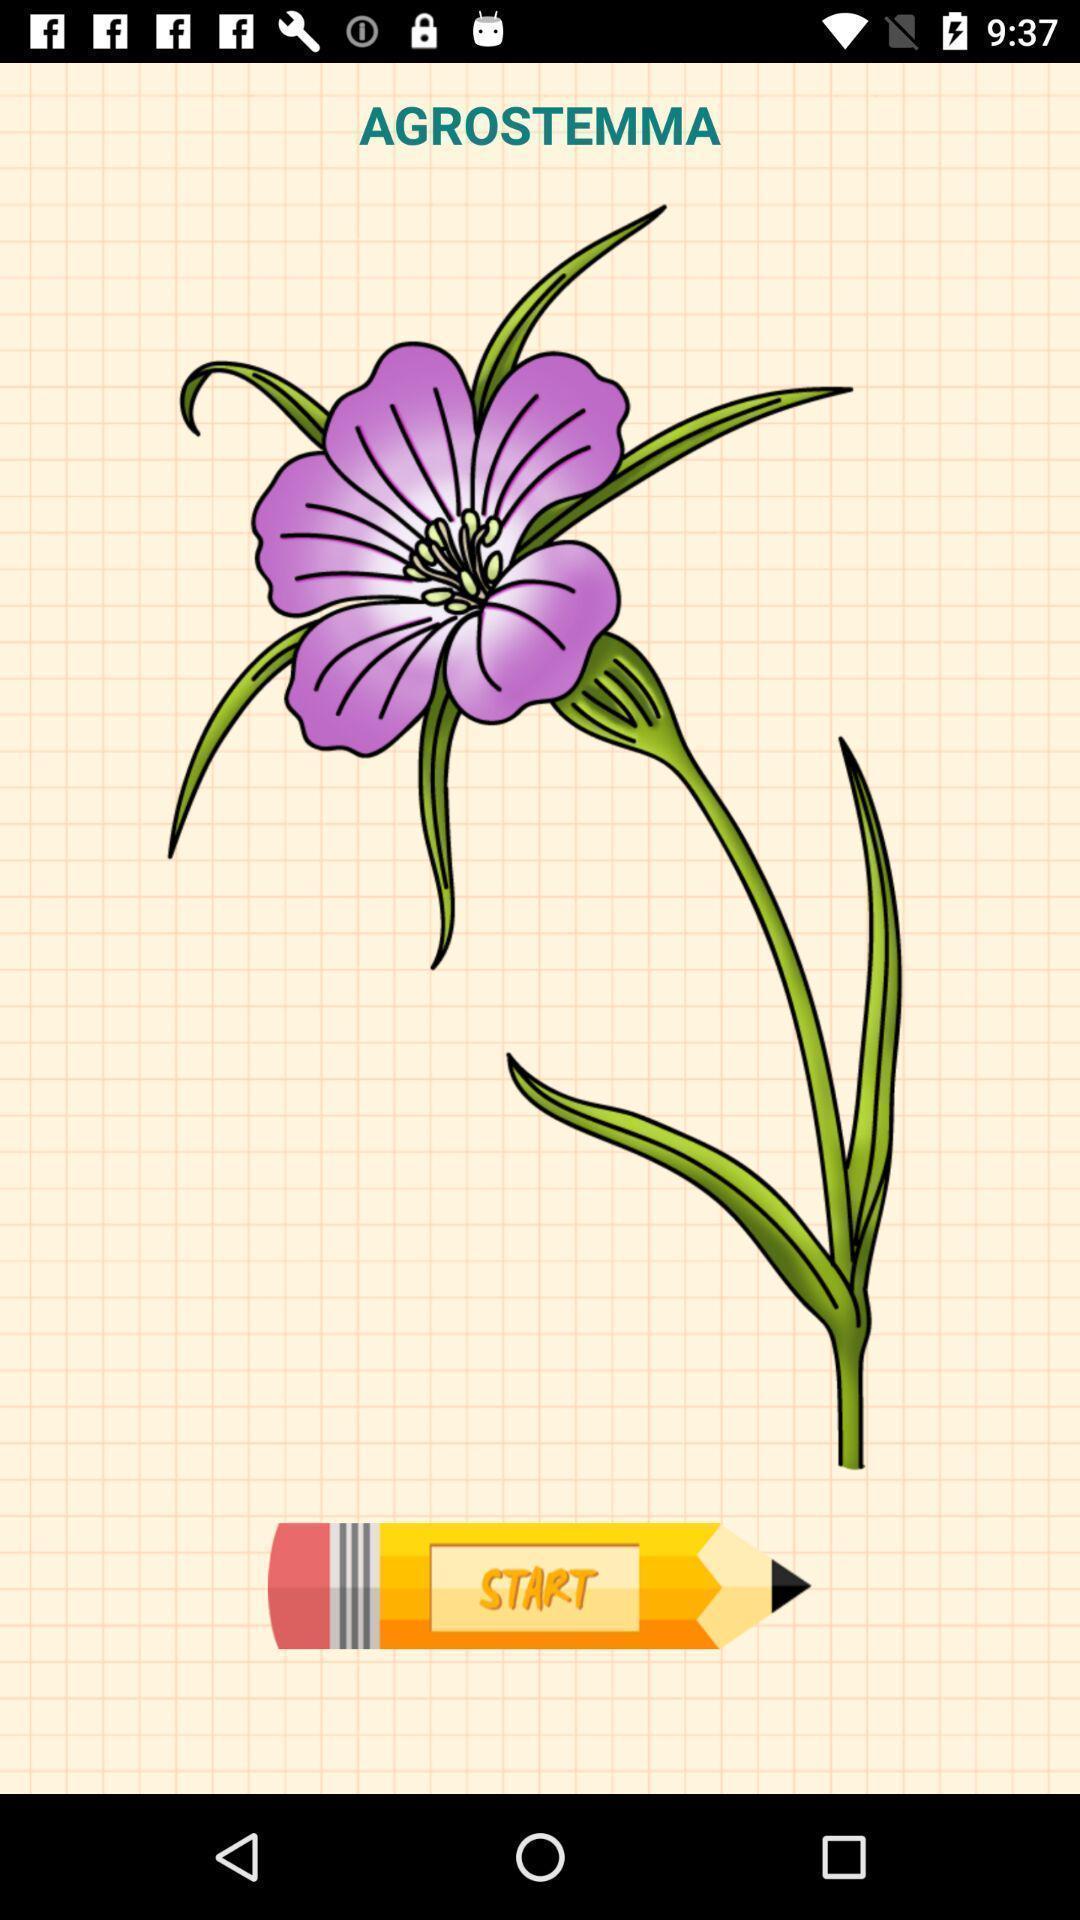Provide a textual representation of this image. Starting page for the drawing application. 